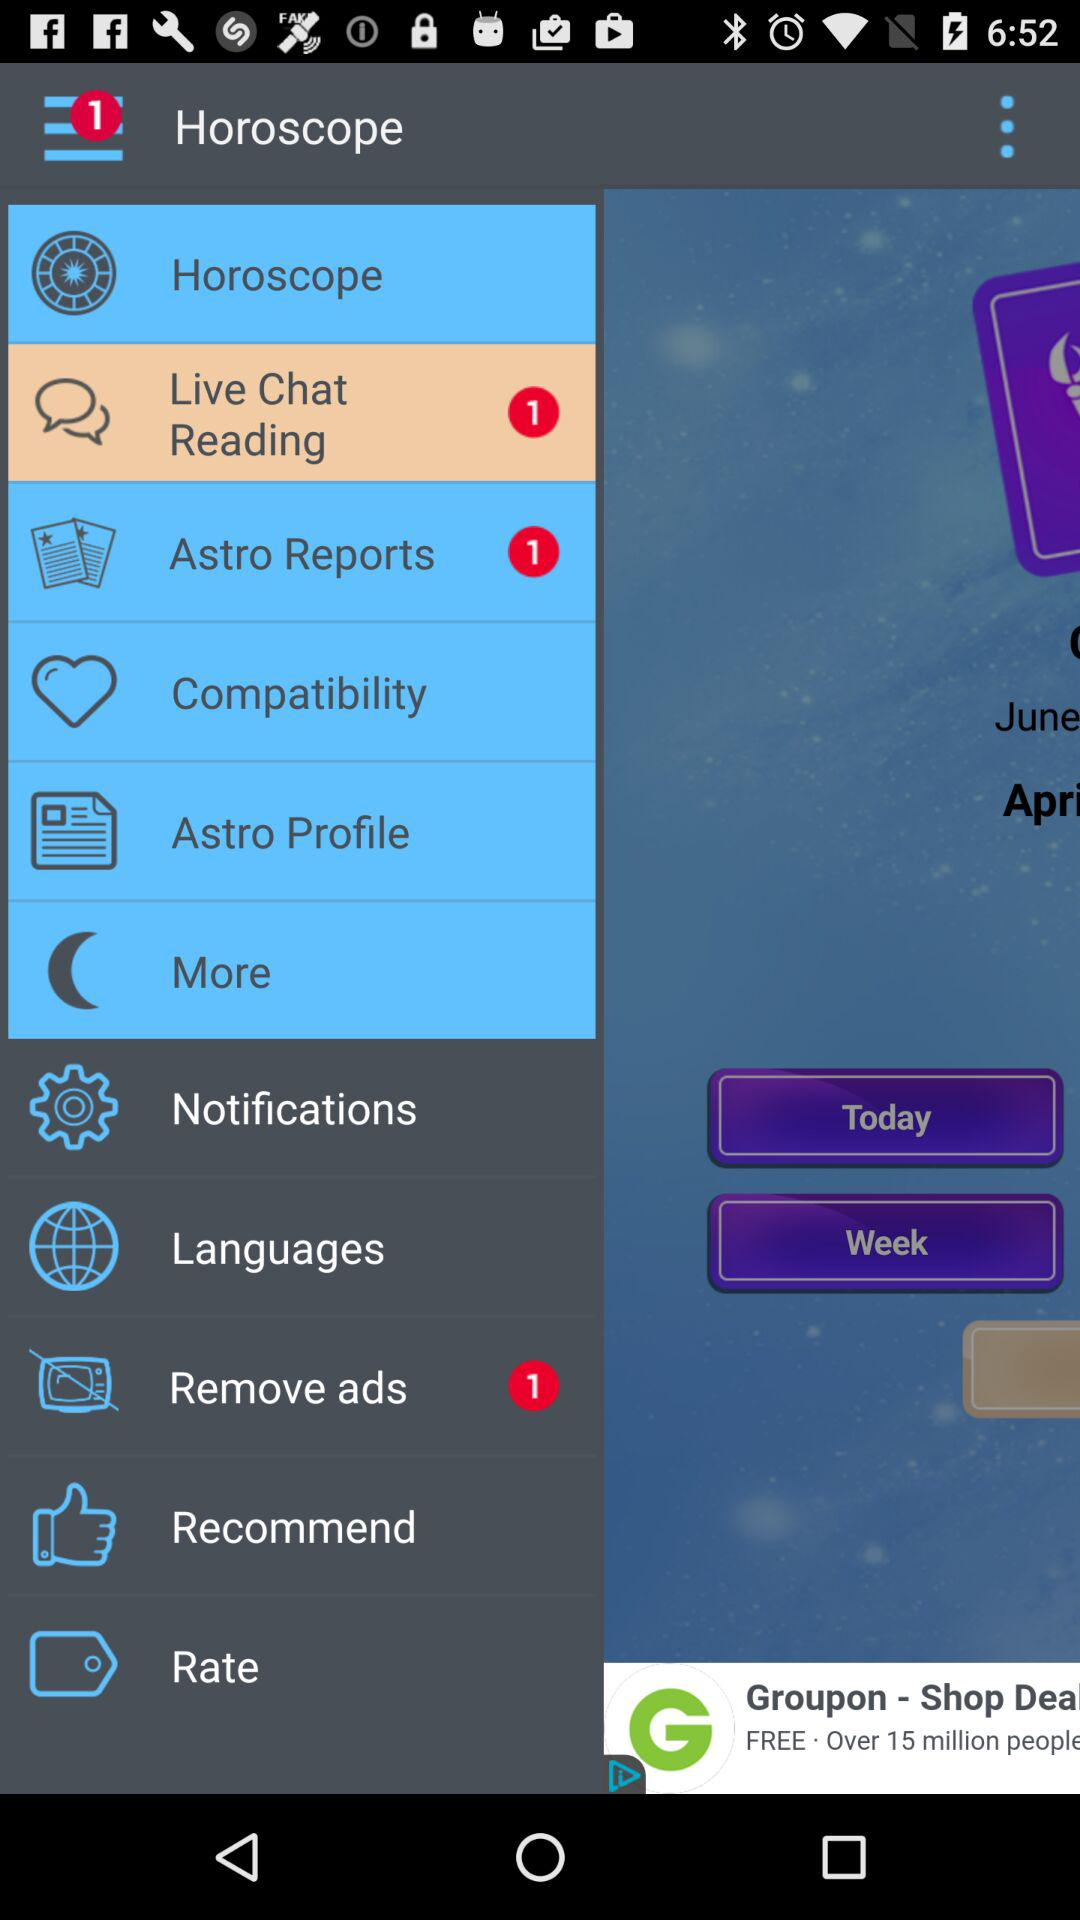How many Astro Reports notifications are there? There is 1 notification. 